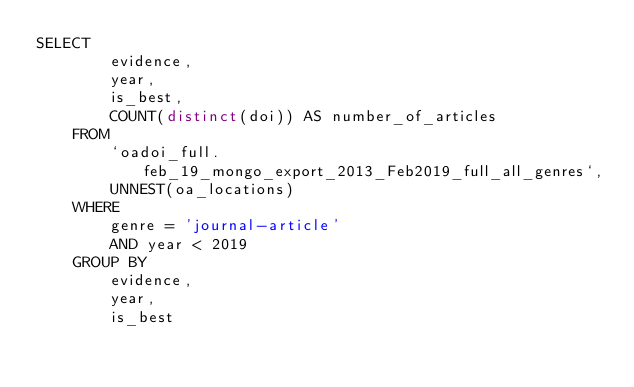Convert code to text. <code><loc_0><loc_0><loc_500><loc_500><_SQL_>SELECT
        evidence,
        year,
        is_best,
        COUNT(distinct(doi)) AS number_of_articles 
    FROM
        `oadoi_full.feb_19_mongo_export_2013_Feb2019_full_all_genres`,
        UNNEST(oa_locations) 
    WHERE
        genre = 'journal-article'
        AND year < 2019 
    GROUP BY
        evidence,
        year,
        is_best</code> 